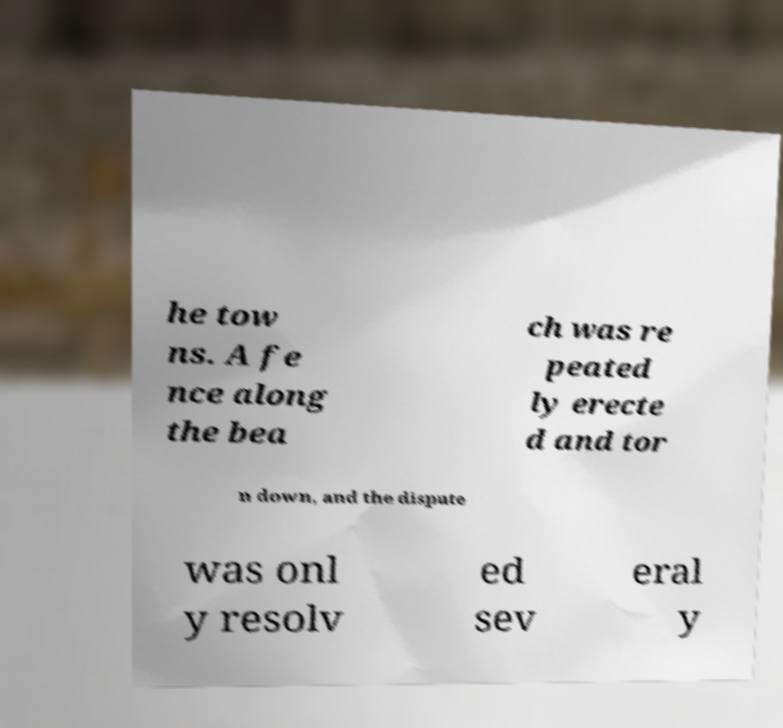Please identify and transcribe the text found in this image. he tow ns. A fe nce along the bea ch was re peated ly erecte d and tor n down, and the dispute was onl y resolv ed sev eral y 